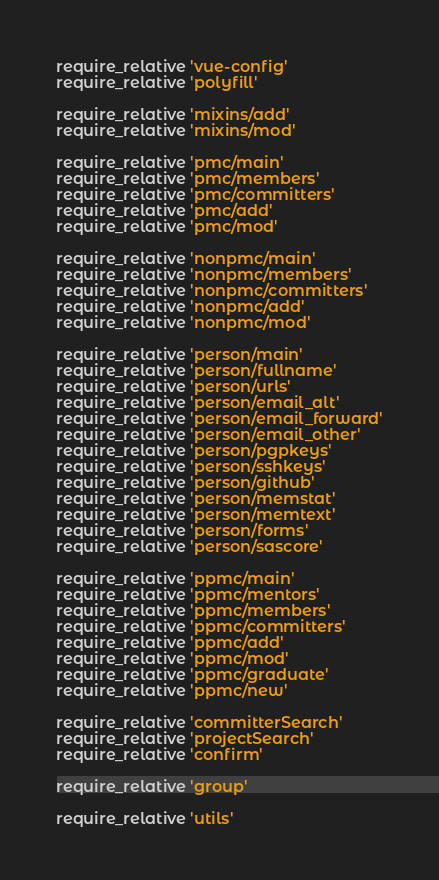<code> <loc_0><loc_0><loc_500><loc_500><_Ruby_>require_relative 'vue-config'
require_relative 'polyfill'

require_relative 'mixins/add'
require_relative 'mixins/mod'

require_relative 'pmc/main'
require_relative 'pmc/members'
require_relative 'pmc/committers'
require_relative 'pmc/add'
require_relative 'pmc/mod'

require_relative 'nonpmc/main'
require_relative 'nonpmc/members'
require_relative 'nonpmc/committers'
require_relative 'nonpmc/add'
require_relative 'nonpmc/mod'

require_relative 'person/main'
require_relative 'person/fullname'
require_relative 'person/urls'
require_relative 'person/email_alt'
require_relative 'person/email_forward'
require_relative 'person/email_other'
require_relative 'person/pgpkeys'
require_relative 'person/sshkeys'
require_relative 'person/github'
require_relative 'person/memstat'
require_relative 'person/memtext'
require_relative 'person/forms'
require_relative 'person/sascore'

require_relative 'ppmc/main'
require_relative 'ppmc/mentors'
require_relative 'ppmc/members'
require_relative 'ppmc/committers'
require_relative 'ppmc/add'
require_relative 'ppmc/mod'
require_relative 'ppmc/graduate'
require_relative 'ppmc/new'

require_relative 'committerSearch'
require_relative 'projectSearch'
require_relative 'confirm'

require_relative 'group'

require_relative 'utils'

</code> 